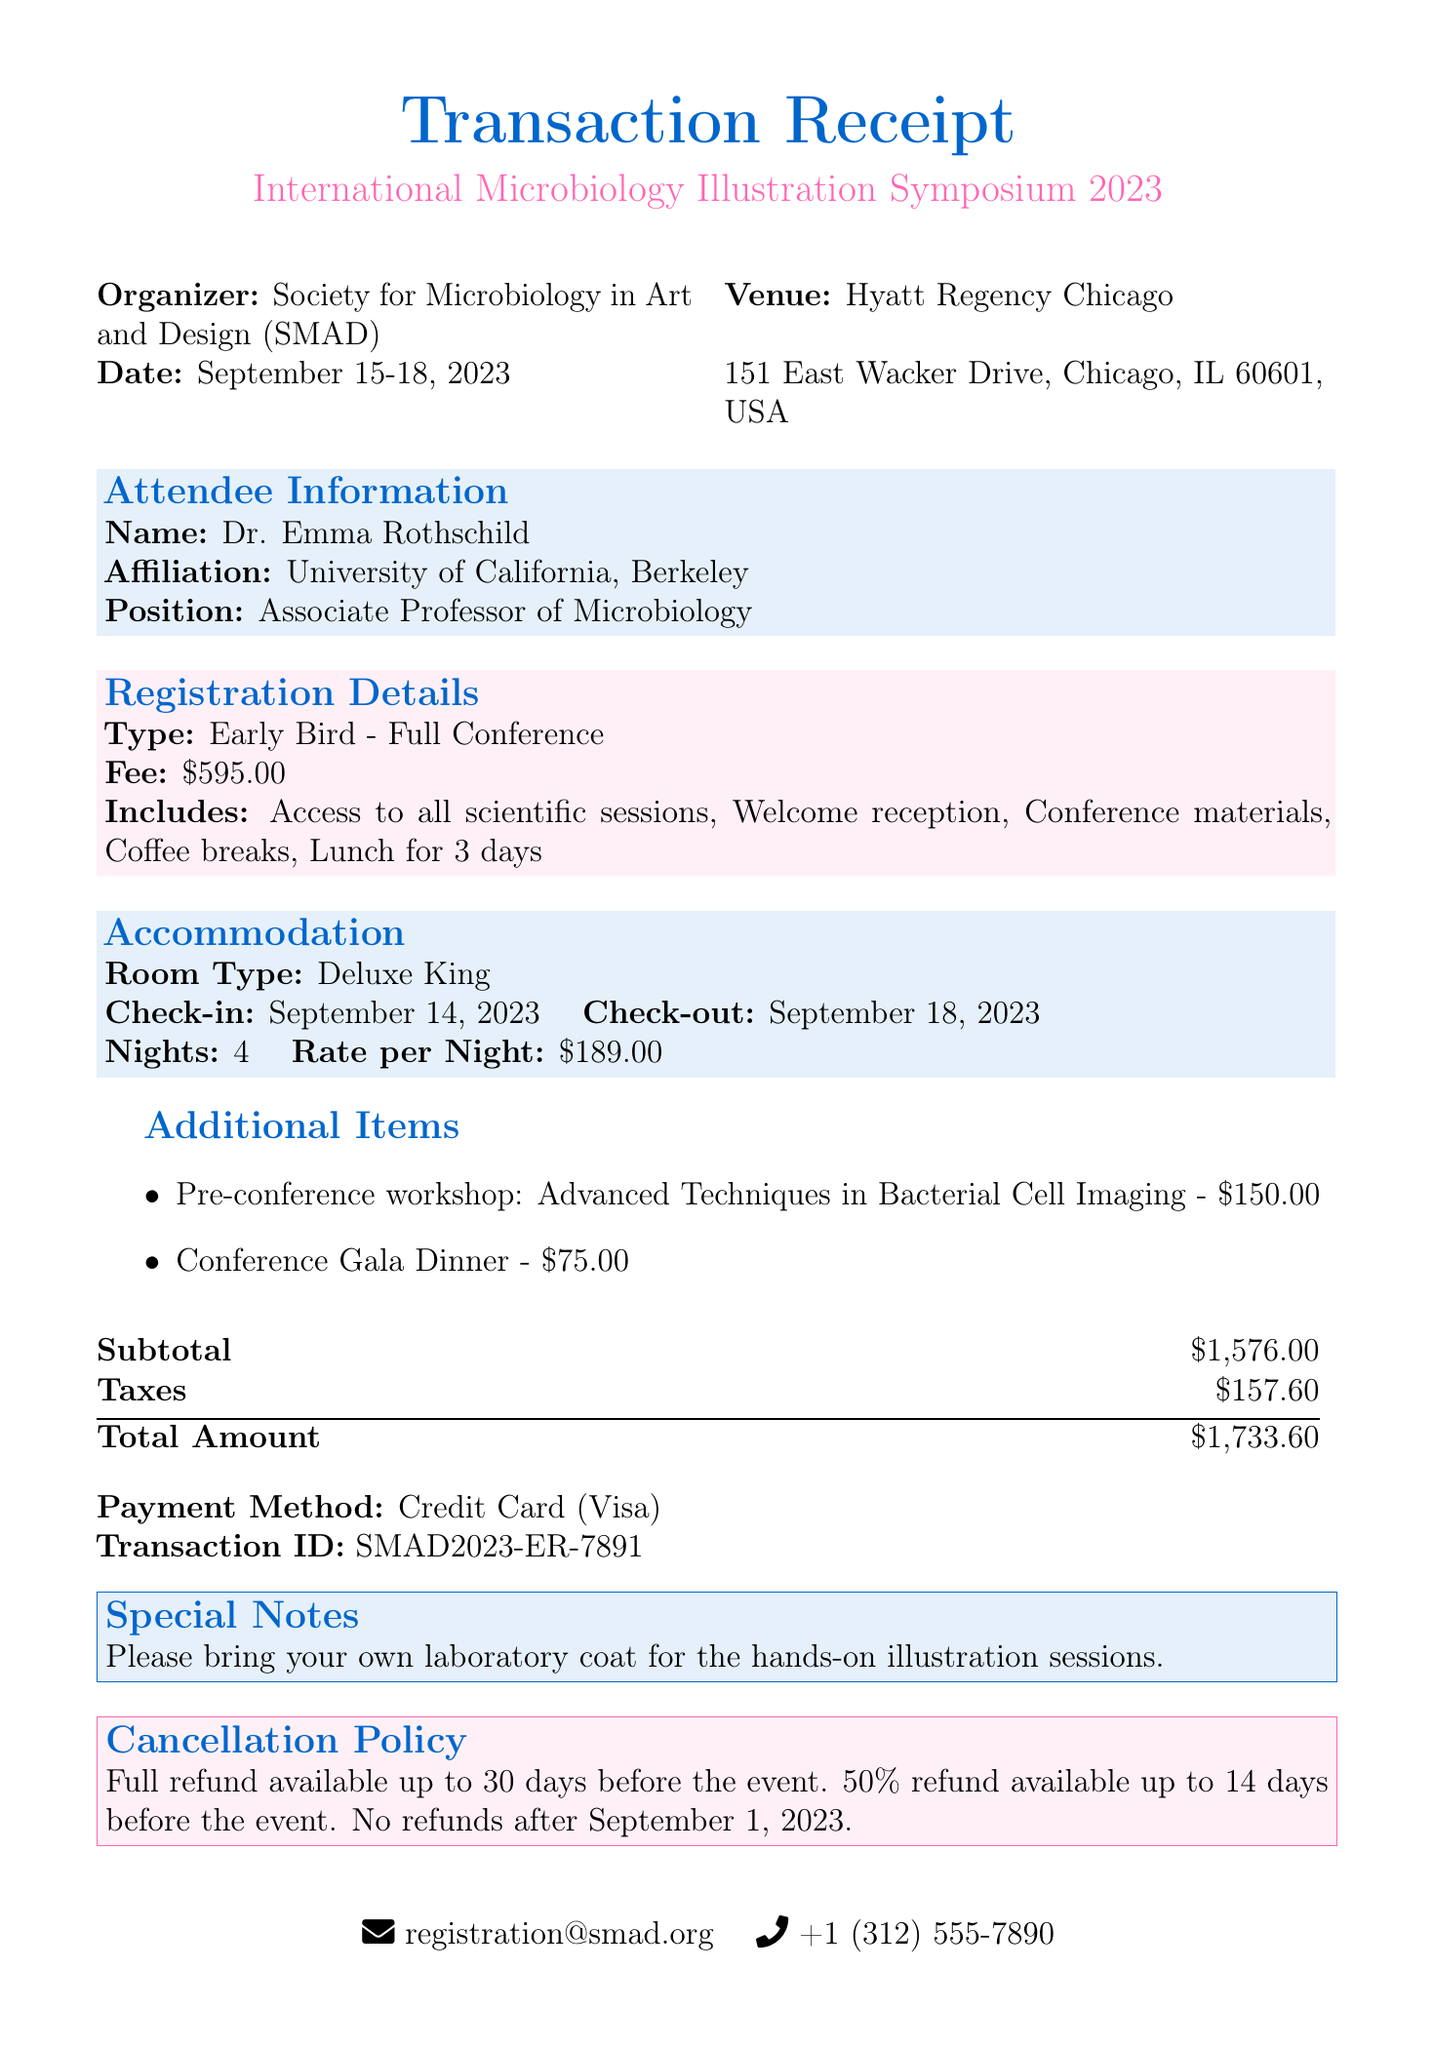what is the name of the conference? The name of the conference is given in the document as "International Microbiology Illustration Symposium 2023."
Answer: International Microbiology Illustration Symposium 2023 who is the organizer of the conference? The organizer is listed as "Society for Microbiology in Art and Design (SMAD)."
Answer: Society for Microbiology in Art and Design (SMAD) how much is the registration fee? The registration fee mentioned in the document is specified as "$595.00."
Answer: $595.00 what is the check-in date for accommodation? The check-in date is provided in the accommodation section of the document as "September 14, 2023."
Answer: September 14, 2023 what is the total amount charged for the transaction? The total amount is calculated by adding the subtotal and taxes, which is "$1,733.60."
Answer: $1,733.60 how many nights will Dr. Emma Rothschild be staying? The number of nights is mentioned in the accommodation section as "4."
Answer: 4 what workshop is offered before the conference? The pre-conference workshop mentioned is "Advanced Techniques in Bacterial Cell Imaging."
Answer: Advanced Techniques in Bacterial Cell Imaging what is the refund policy after September 1, 2023? The cancellation policy states that there are "No refunds after September 1, 2023."
Answer: No refunds after September 1, 2023 what payment method was used for the transaction? The payment method indicated in the document is "Credit Card (Visa)."
Answer: Credit Card (Visa) 